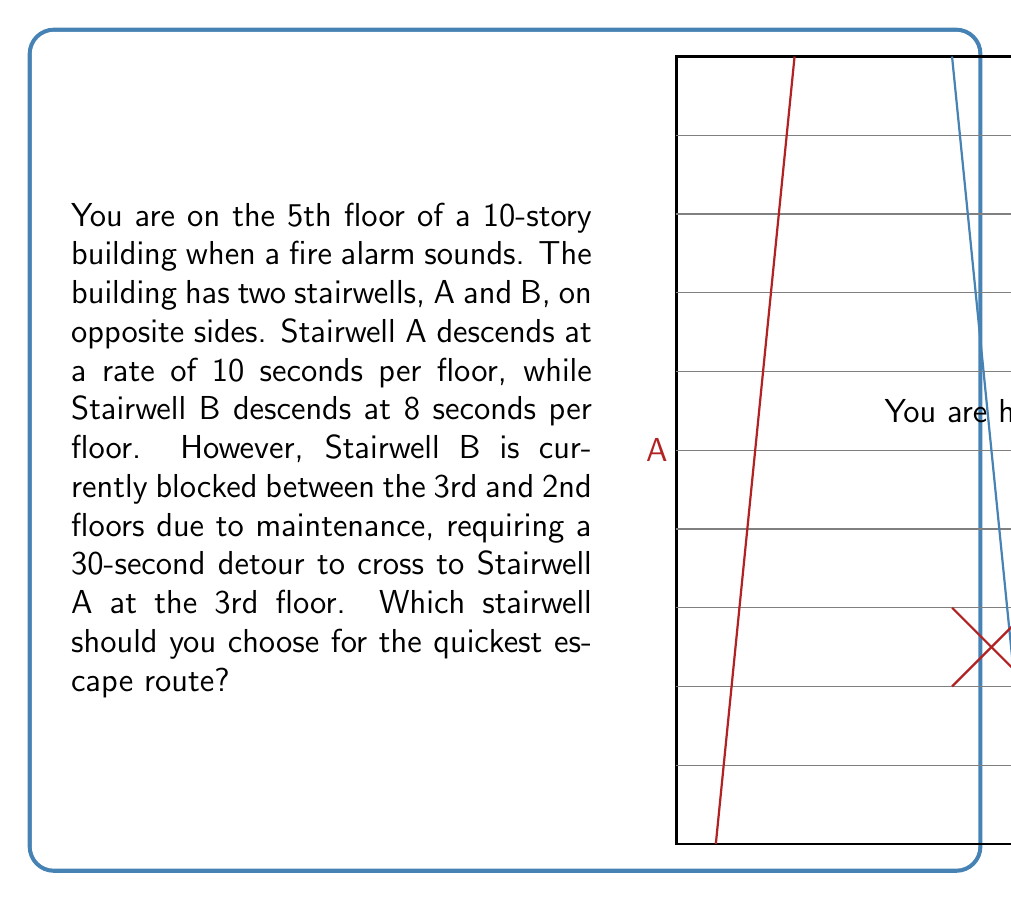Solve this math problem. Let's break this down step-by-step:

1) You start on the 5th floor, so you need to descend 5 floors to reach the ground level.

2) For Stairwell A:
   - Time to descend = 5 floors × 10 seconds/floor = 50 seconds

3) For Stairwell B:
   - Time to descend to 3rd floor = 2 floors × 8 seconds/floor = 16 seconds
   - Time for detour at 3rd floor = 30 seconds
   - Time to descend remaining 3 floors via Stairwell A = 3 floors × 10 seconds/floor = 30 seconds
   - Total time = 16 + 30 + 30 = 76 seconds

4) Let's express this mathematically:
   
   Stairwell A time: $T_A = 5 \times 10 = 50$ seconds
   
   Stairwell B time: $T_B = (2 \times 8) + 30 + (3 \times 10) = 76$ seconds

5) Comparing the two times:
   $T_A < T_B$
   $50 < 76$

Therefore, Stairwell A provides the quickest escape route.
Answer: Stairwell A 